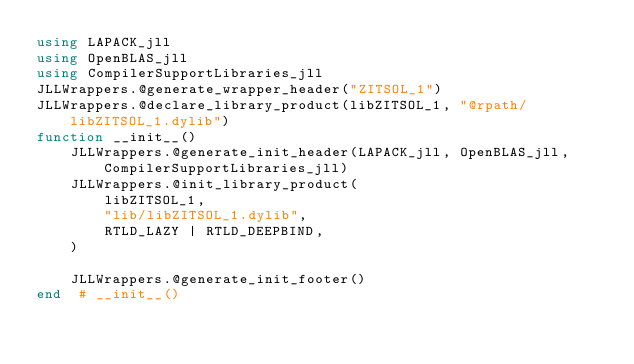<code> <loc_0><loc_0><loc_500><loc_500><_Julia_>using LAPACK_jll
using OpenBLAS_jll
using CompilerSupportLibraries_jll
JLLWrappers.@generate_wrapper_header("ZITSOL_1")
JLLWrappers.@declare_library_product(libZITSOL_1, "@rpath/libZITSOL_1.dylib")
function __init__()
    JLLWrappers.@generate_init_header(LAPACK_jll, OpenBLAS_jll, CompilerSupportLibraries_jll)
    JLLWrappers.@init_library_product(
        libZITSOL_1,
        "lib/libZITSOL_1.dylib",
        RTLD_LAZY | RTLD_DEEPBIND,
    )

    JLLWrappers.@generate_init_footer()
end  # __init__()
</code> 